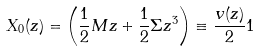<formula> <loc_0><loc_0><loc_500><loc_500>X _ { 0 } ( z ) = \left ( \frac { 1 } { 2 } M z + \frac { 1 } { 2 } \Sigma z ^ { 3 } \right ) \equiv \frac { v ( z ) } { 2 } { 1 }</formula> 